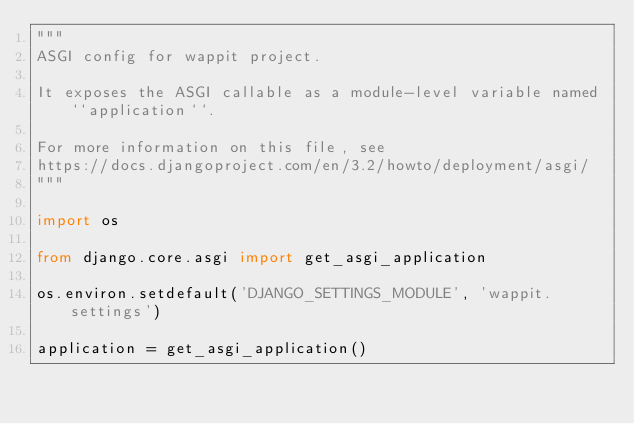Convert code to text. <code><loc_0><loc_0><loc_500><loc_500><_Python_>"""
ASGI config for wappit project.

It exposes the ASGI callable as a module-level variable named ``application``.

For more information on this file, see
https://docs.djangoproject.com/en/3.2/howto/deployment/asgi/
"""

import os

from django.core.asgi import get_asgi_application

os.environ.setdefault('DJANGO_SETTINGS_MODULE', 'wappit.settings')

application = get_asgi_application()
</code> 